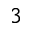<formula> <loc_0><loc_0><loc_500><loc_500>^ { 3 }</formula> 